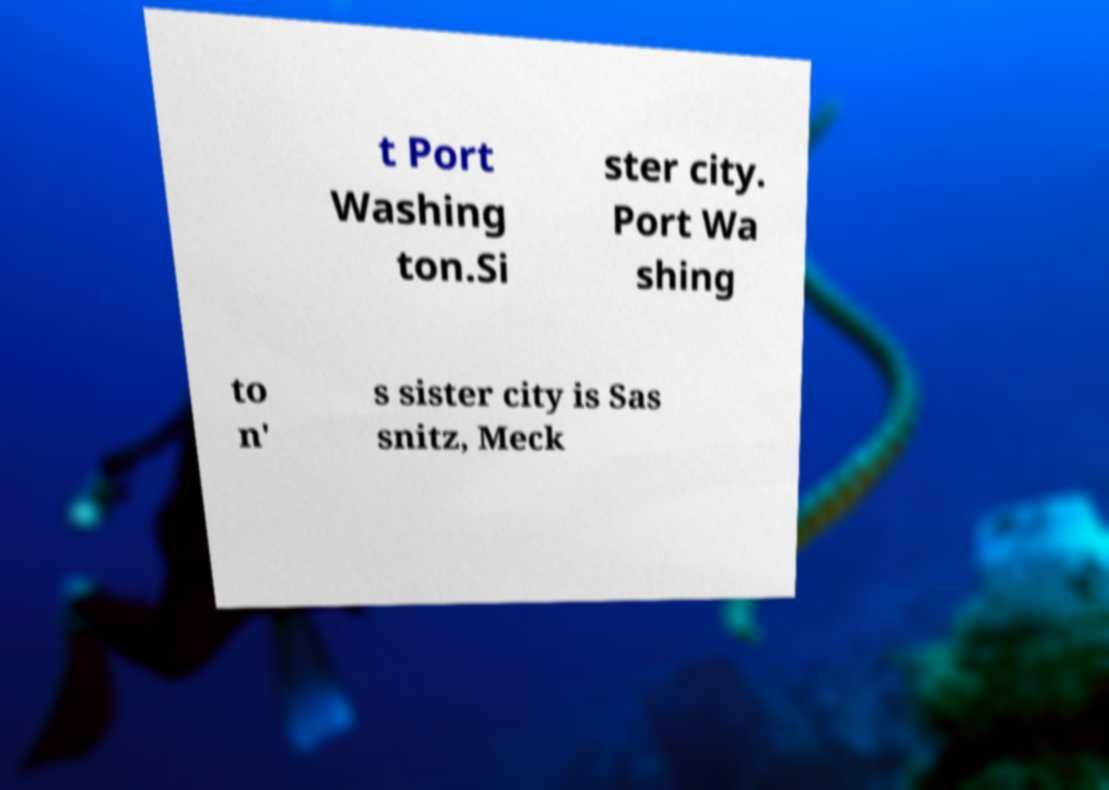For documentation purposes, I need the text within this image transcribed. Could you provide that? t Port Washing ton.Si ster city. Port Wa shing to n' s sister city is Sas snitz, Meck 